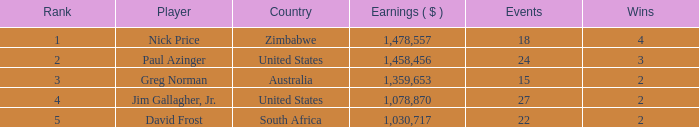How many happenings are in south africa? 22.0. 